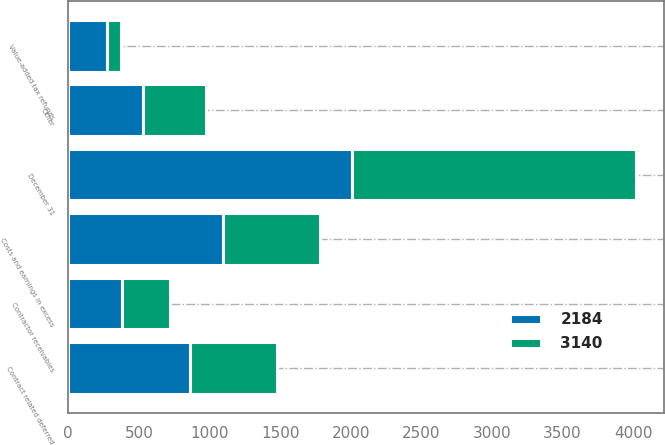<chart> <loc_0><loc_0><loc_500><loc_500><stacked_bar_chart><ecel><fcel>December 31<fcel>Costs and earnings in excess<fcel>Contract related deferred<fcel>Contractor receivables<fcel>Value-added tax refunds<fcel>Other<nl><fcel>3140<fcel>2009<fcel>686<fcel>616<fcel>342<fcel>95<fcel>445<nl><fcel>2184<fcel>2008<fcel>1094<fcel>861<fcel>378<fcel>278<fcel>529<nl></chart> 